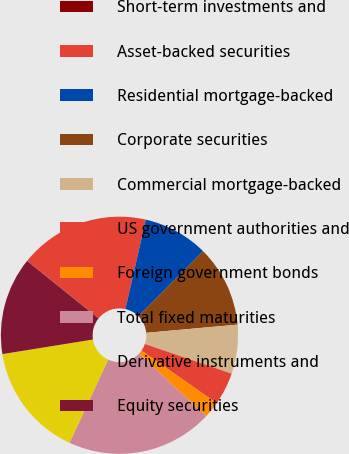<chart> <loc_0><loc_0><loc_500><loc_500><pie_chart><fcel>Short-term investments and<fcel>Asset-backed securities<fcel>Residential mortgage-backed<fcel>Corporate securities<fcel>Commercial mortgage-backed<fcel>US government authorities and<fcel>Foreign government bonds<fcel>Total fixed maturities<fcel>Derivative instruments and<fcel>Equity securities<nl><fcel>0.04%<fcel>17.75%<fcel>8.89%<fcel>11.11%<fcel>6.68%<fcel>4.46%<fcel>2.25%<fcel>19.96%<fcel>15.54%<fcel>13.32%<nl></chart> 